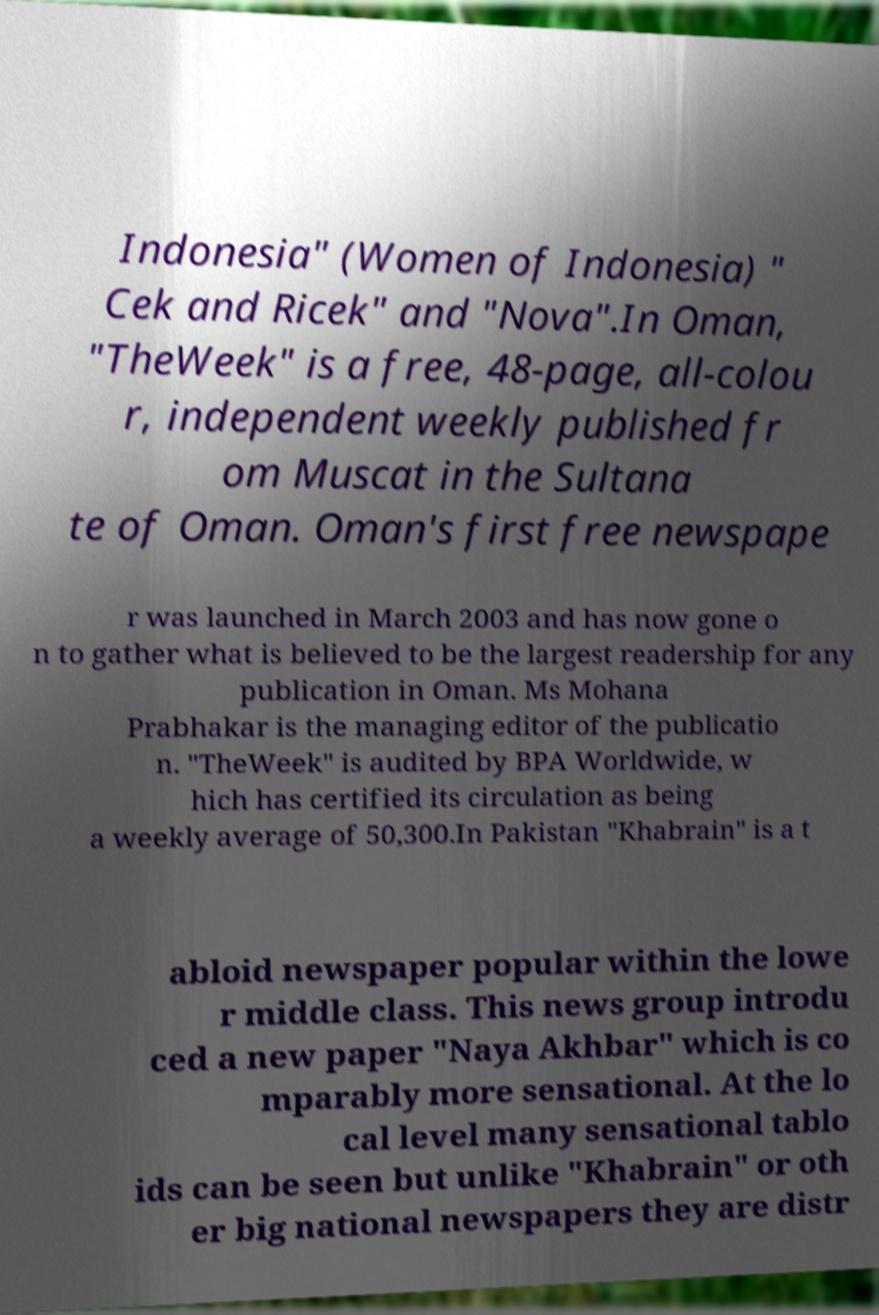For documentation purposes, I need the text within this image transcribed. Could you provide that? Indonesia" (Women of Indonesia) " Cek and Ricek" and "Nova".In Oman, "TheWeek" is a free, 48-page, all-colou r, independent weekly published fr om Muscat in the Sultana te of Oman. Oman's first free newspape r was launched in March 2003 and has now gone o n to gather what is believed to be the largest readership for any publication in Oman. Ms Mohana Prabhakar is the managing editor of the publicatio n. "TheWeek" is audited by BPA Worldwide, w hich has certified its circulation as being a weekly average of 50,300.In Pakistan "Khabrain" is a t abloid newspaper popular within the lowe r middle class. This news group introdu ced a new paper "Naya Akhbar" which is co mparably more sensational. At the lo cal level many sensational tablo ids can be seen but unlike "Khabrain" or oth er big national newspapers they are distr 